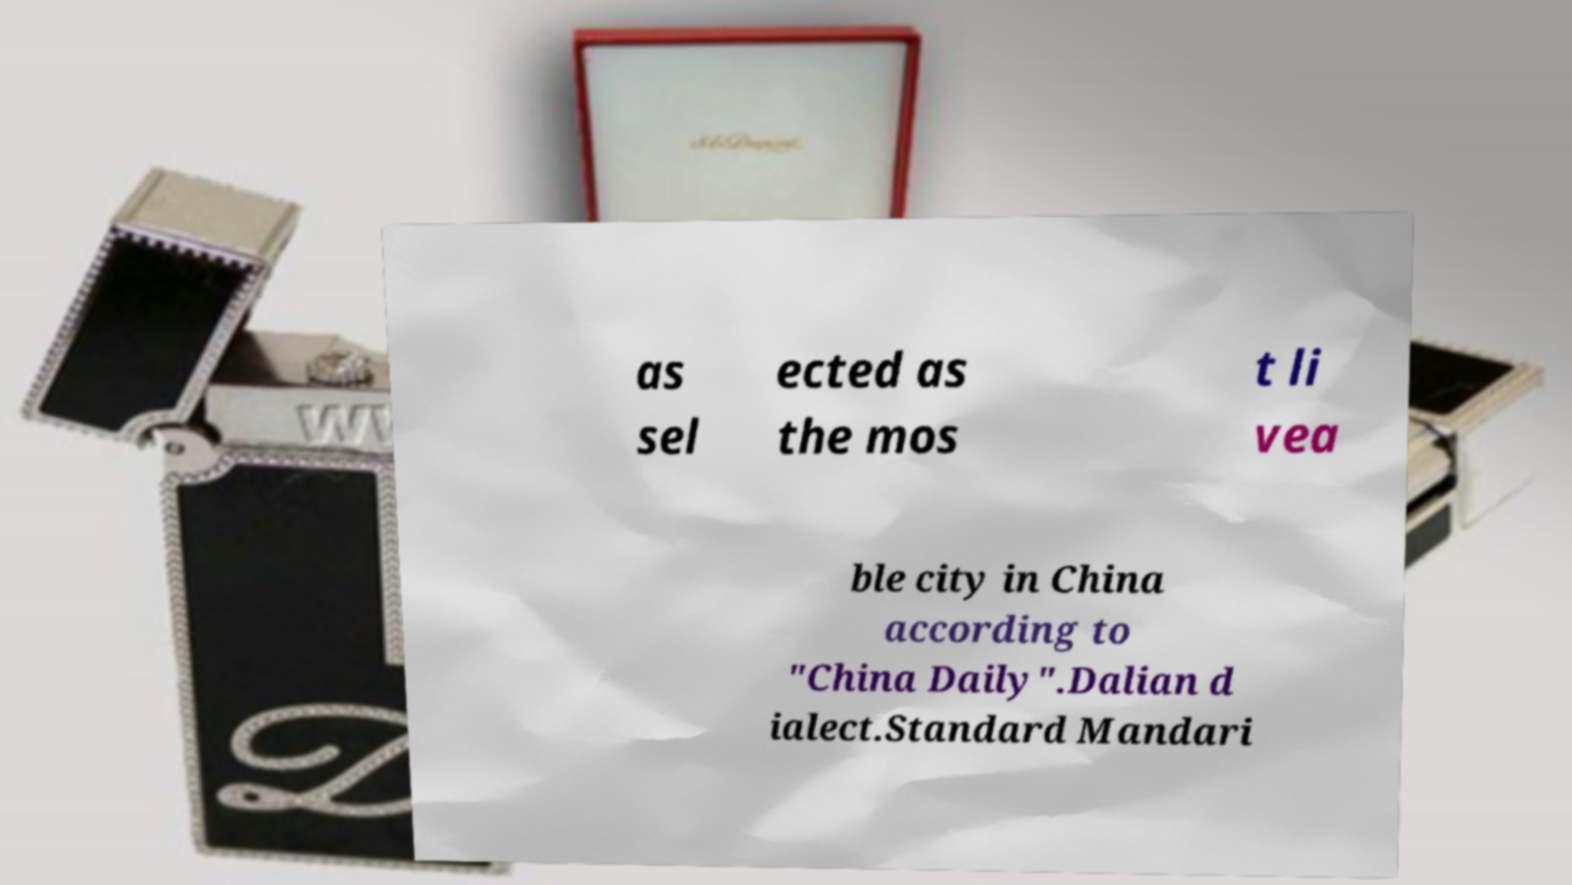Can you accurately transcribe the text from the provided image for me? as sel ected as the mos t li vea ble city in China according to "China Daily".Dalian d ialect.Standard Mandari 